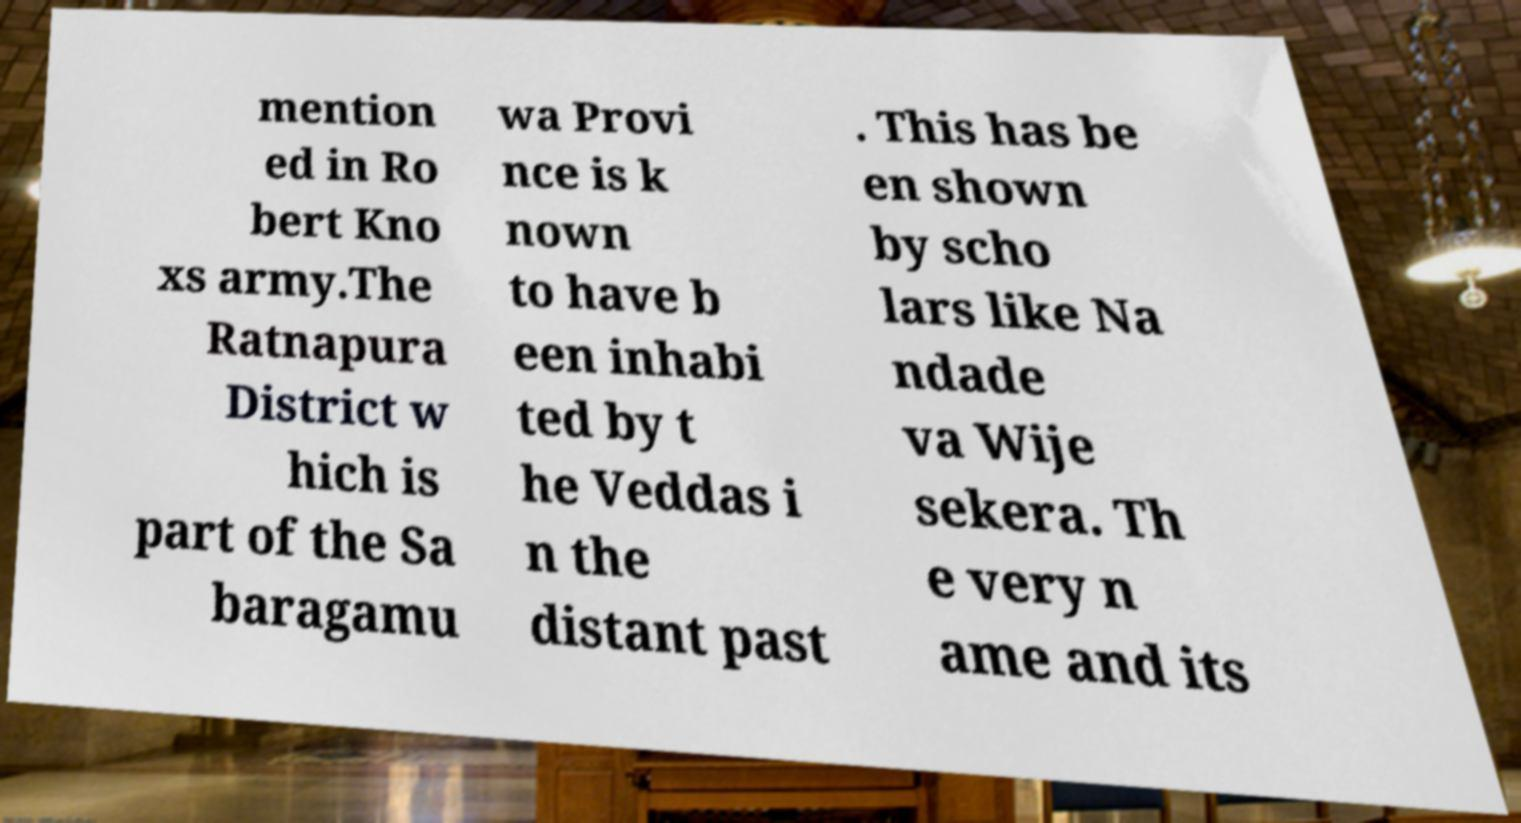Please identify and transcribe the text found in this image. mention ed in Ro bert Kno xs army.The Ratnapura District w hich is part of the Sa baragamu wa Provi nce is k nown to have b een inhabi ted by t he Veddas i n the distant past . This has be en shown by scho lars like Na ndade va Wije sekera. Th e very n ame and its 